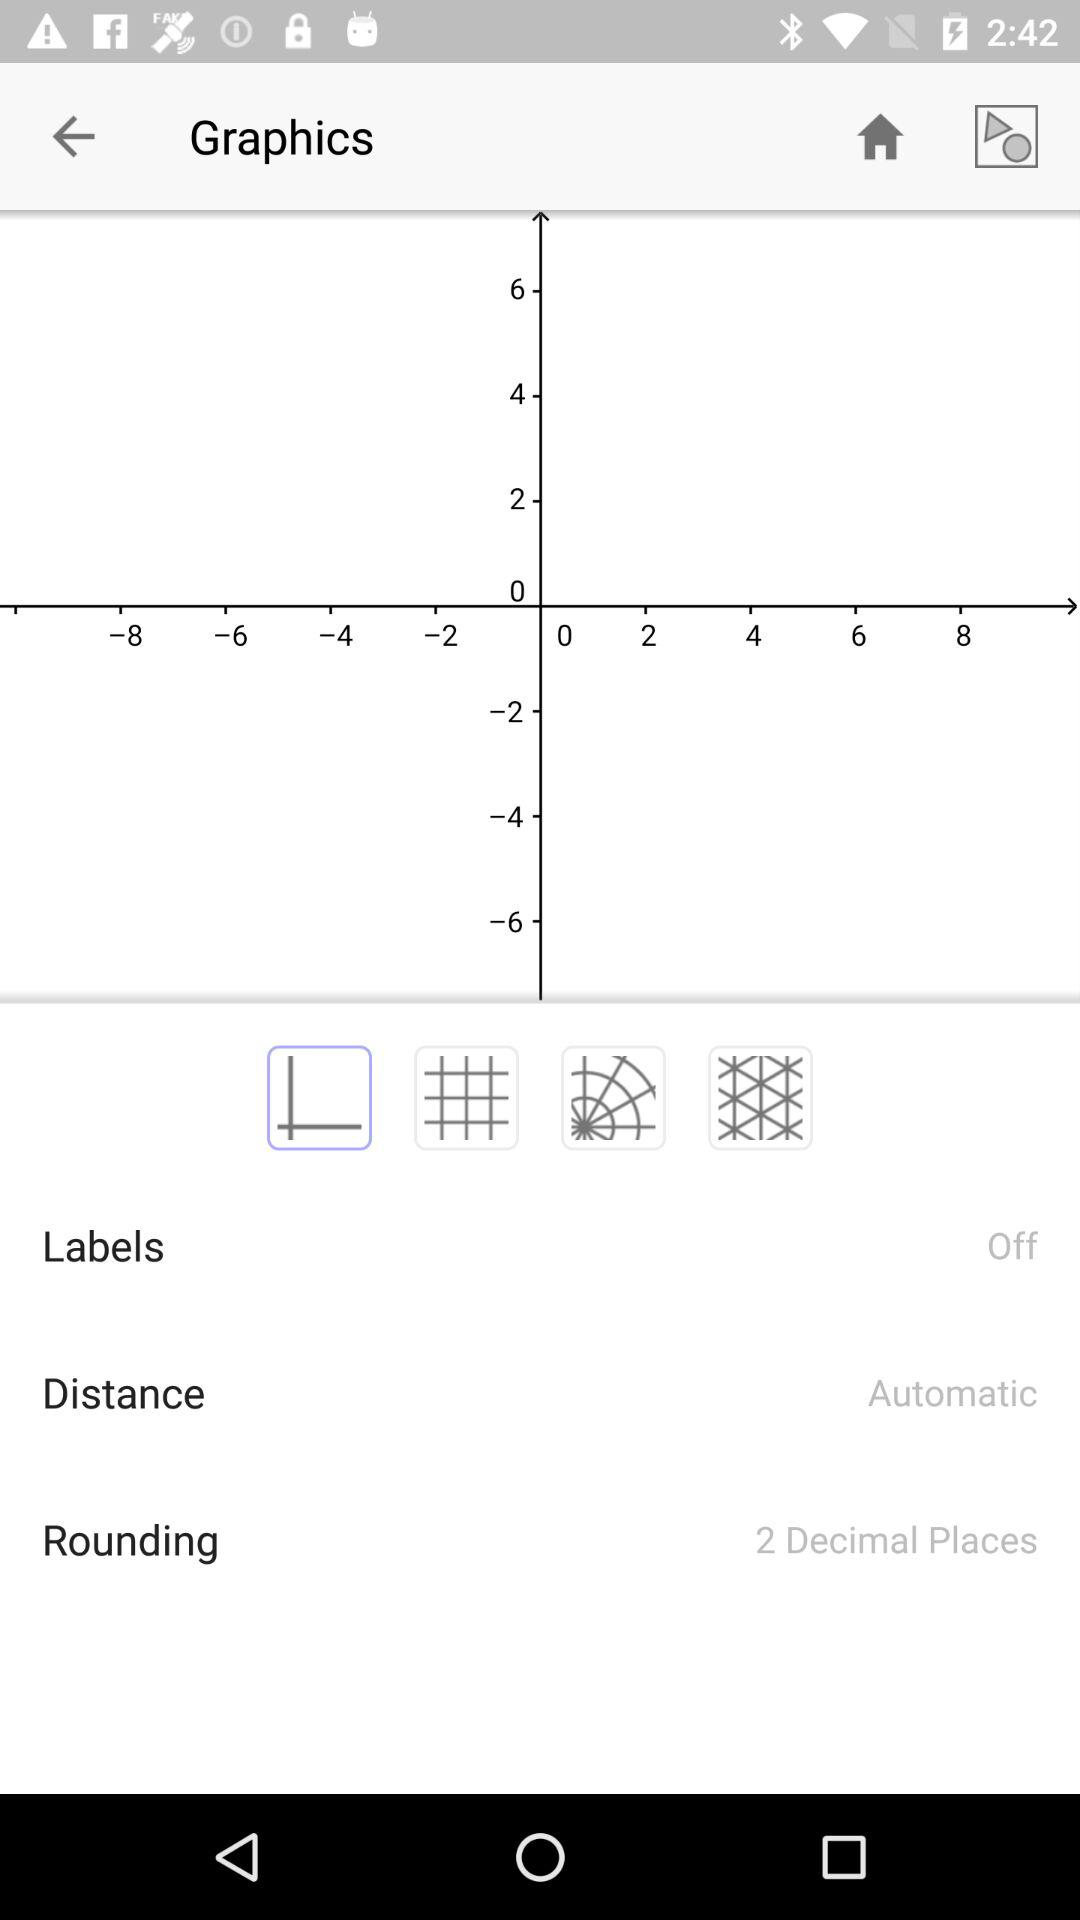How many decimal places does the rounding have?
Answer the question using a single word or phrase. 2 